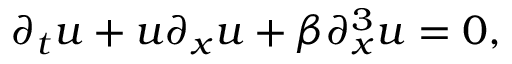<formula> <loc_0><loc_0><loc_500><loc_500>\partial _ { t } u + u \partial _ { x } u + \beta \partial _ { x } ^ { 3 } u = 0 ,</formula> 